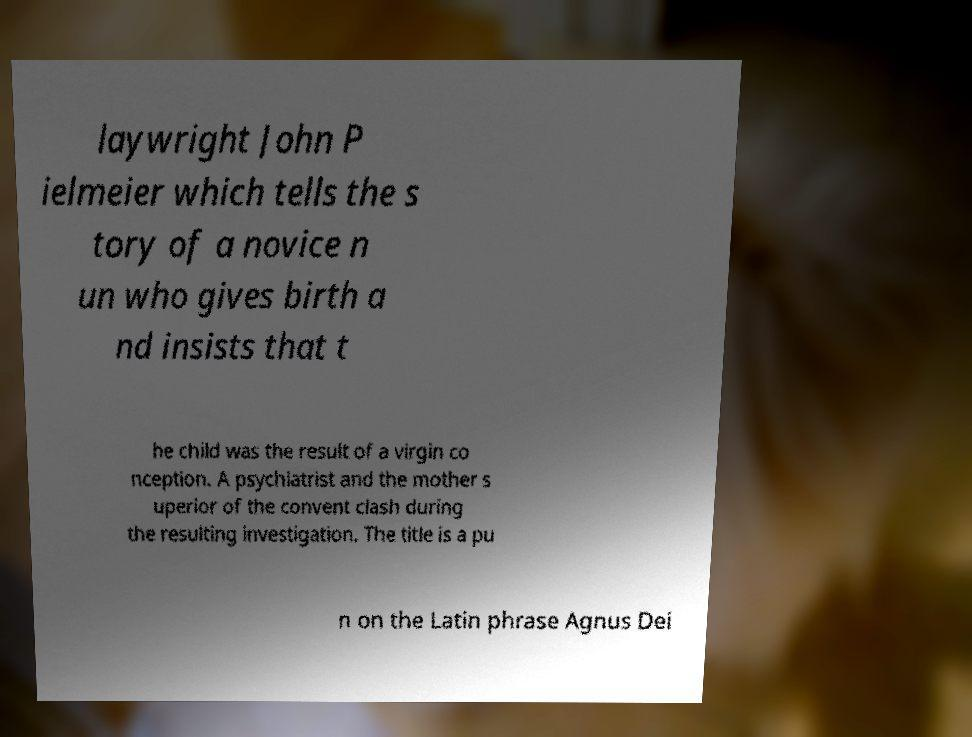For documentation purposes, I need the text within this image transcribed. Could you provide that? laywright John P ielmeier which tells the s tory of a novice n un who gives birth a nd insists that t he child was the result of a virgin co nception. A psychiatrist and the mother s uperior of the convent clash during the resulting investigation. The title is a pu n on the Latin phrase Agnus Dei 